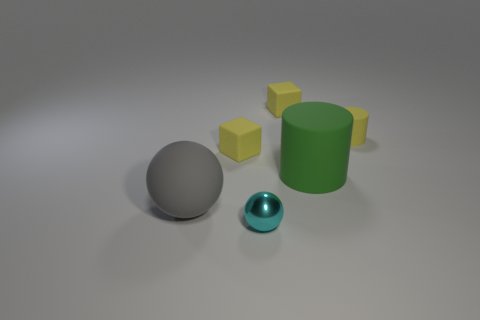What material is the cyan sphere?
Offer a terse response. Metal. What color is the matte cylinder that is the same size as the metal object?
Ensure brevity in your answer.  Yellow. Does the large gray object have the same shape as the large green matte object?
Provide a succinct answer. No. There is a tiny yellow object that is left of the small cylinder and to the right of the small metallic sphere; what material is it?
Keep it short and to the point. Rubber. What size is the yellow rubber cylinder?
Your response must be concise. Small. What is the color of the large matte thing that is the same shape as the tiny cyan shiny thing?
Offer a very short reply. Gray. Is there anything else that is the same color as the large rubber cylinder?
Ensure brevity in your answer.  No. There is a yellow thing left of the cyan shiny ball; is its size the same as the yellow cube right of the tiny metallic object?
Make the answer very short. Yes. Are there the same number of spheres to the right of the tiny cylinder and large gray matte objects behind the green cylinder?
Offer a very short reply. Yes. Is the size of the metallic sphere the same as the yellow rubber block that is behind the tiny yellow cylinder?
Keep it short and to the point. Yes. 